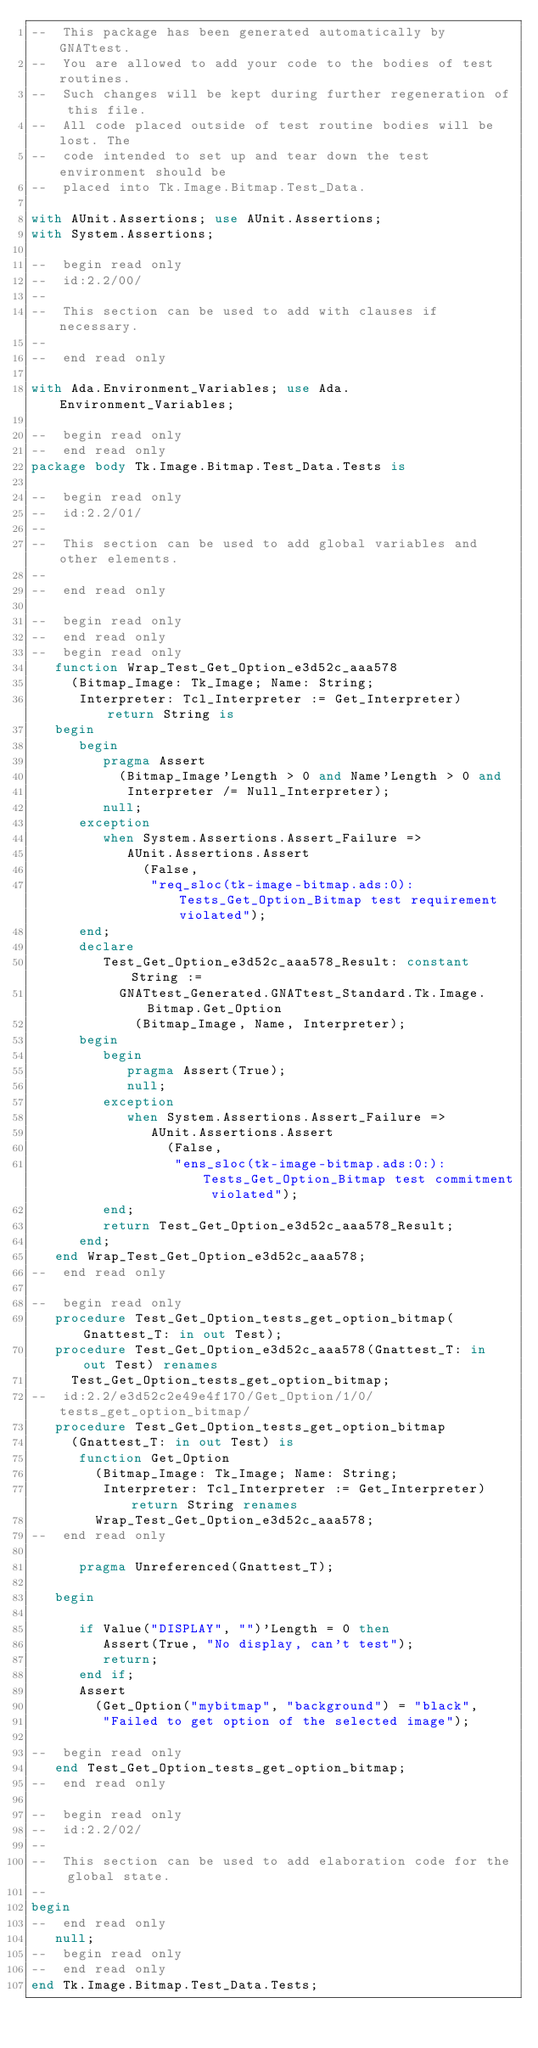Convert code to text. <code><loc_0><loc_0><loc_500><loc_500><_Ada_>--  This package has been generated automatically by GNATtest.
--  You are allowed to add your code to the bodies of test routines.
--  Such changes will be kept during further regeneration of this file.
--  All code placed outside of test routine bodies will be lost. The
--  code intended to set up and tear down the test environment should be
--  placed into Tk.Image.Bitmap.Test_Data.

with AUnit.Assertions; use AUnit.Assertions;
with System.Assertions;

--  begin read only
--  id:2.2/00/
--
--  This section can be used to add with clauses if necessary.
--
--  end read only

with Ada.Environment_Variables; use Ada.Environment_Variables;

--  begin read only
--  end read only
package body Tk.Image.Bitmap.Test_Data.Tests is

--  begin read only
--  id:2.2/01/
--
--  This section can be used to add global variables and other elements.
--
--  end read only

--  begin read only
--  end read only
--  begin read only
   function Wrap_Test_Get_Option_e3d52c_aaa578
     (Bitmap_Image: Tk_Image; Name: String;
      Interpreter: Tcl_Interpreter := Get_Interpreter) return String is
   begin
      begin
         pragma Assert
           (Bitmap_Image'Length > 0 and Name'Length > 0 and
            Interpreter /= Null_Interpreter);
         null;
      exception
         when System.Assertions.Assert_Failure =>
            AUnit.Assertions.Assert
              (False,
               "req_sloc(tk-image-bitmap.ads:0):Tests_Get_Option_Bitmap test requirement violated");
      end;
      declare
         Test_Get_Option_e3d52c_aaa578_Result: constant String :=
           GNATtest_Generated.GNATtest_Standard.Tk.Image.Bitmap.Get_Option
             (Bitmap_Image, Name, Interpreter);
      begin
         begin
            pragma Assert(True);
            null;
         exception
            when System.Assertions.Assert_Failure =>
               AUnit.Assertions.Assert
                 (False,
                  "ens_sloc(tk-image-bitmap.ads:0:):Tests_Get_Option_Bitmap test commitment violated");
         end;
         return Test_Get_Option_e3d52c_aaa578_Result;
      end;
   end Wrap_Test_Get_Option_e3d52c_aaa578;
--  end read only

--  begin read only
   procedure Test_Get_Option_tests_get_option_bitmap(Gnattest_T: in out Test);
   procedure Test_Get_Option_e3d52c_aaa578(Gnattest_T: in out Test) renames
     Test_Get_Option_tests_get_option_bitmap;
--  id:2.2/e3d52c2e49e4f170/Get_Option/1/0/tests_get_option_bitmap/
   procedure Test_Get_Option_tests_get_option_bitmap
     (Gnattest_T: in out Test) is
      function Get_Option
        (Bitmap_Image: Tk_Image; Name: String;
         Interpreter: Tcl_Interpreter := Get_Interpreter) return String renames
        Wrap_Test_Get_Option_e3d52c_aaa578;
--  end read only

      pragma Unreferenced(Gnattest_T);

   begin

      if Value("DISPLAY", "")'Length = 0 then
         Assert(True, "No display, can't test");
         return;
      end if;
      Assert
        (Get_Option("mybitmap", "background") = "black",
         "Failed to get option of the selected image");

--  begin read only
   end Test_Get_Option_tests_get_option_bitmap;
--  end read only

--  begin read only
--  id:2.2/02/
--
--  This section can be used to add elaboration code for the global state.
--
begin
--  end read only
   null;
--  begin read only
--  end read only
end Tk.Image.Bitmap.Test_Data.Tests;
</code> 